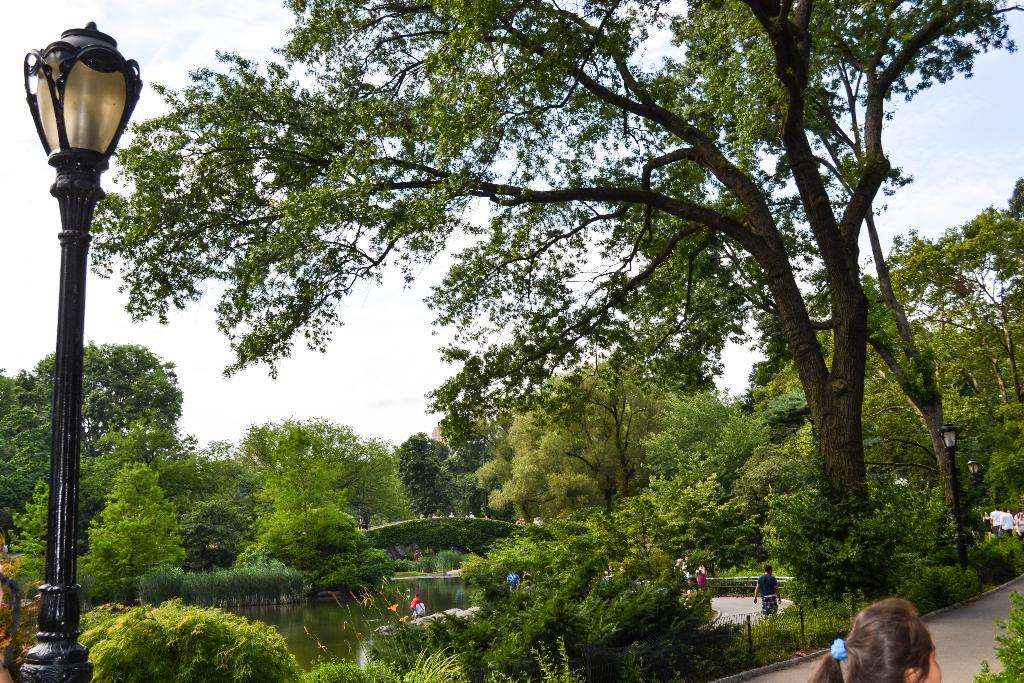What is the primary feature of the landscape in the image? There are many trees in the image. What can be seen in the middle of the image? There is water in the middle of the image. How many people are visible in the image? There are few persons in the image. What object is located on the left side of the image? There is a lamp on the left side of the image. What type of path is present on the right side of the image? There is a path on the right side of the image. How many snails can be seen crawling on the elbow in the image? There is no elbow or snails present in the image. 